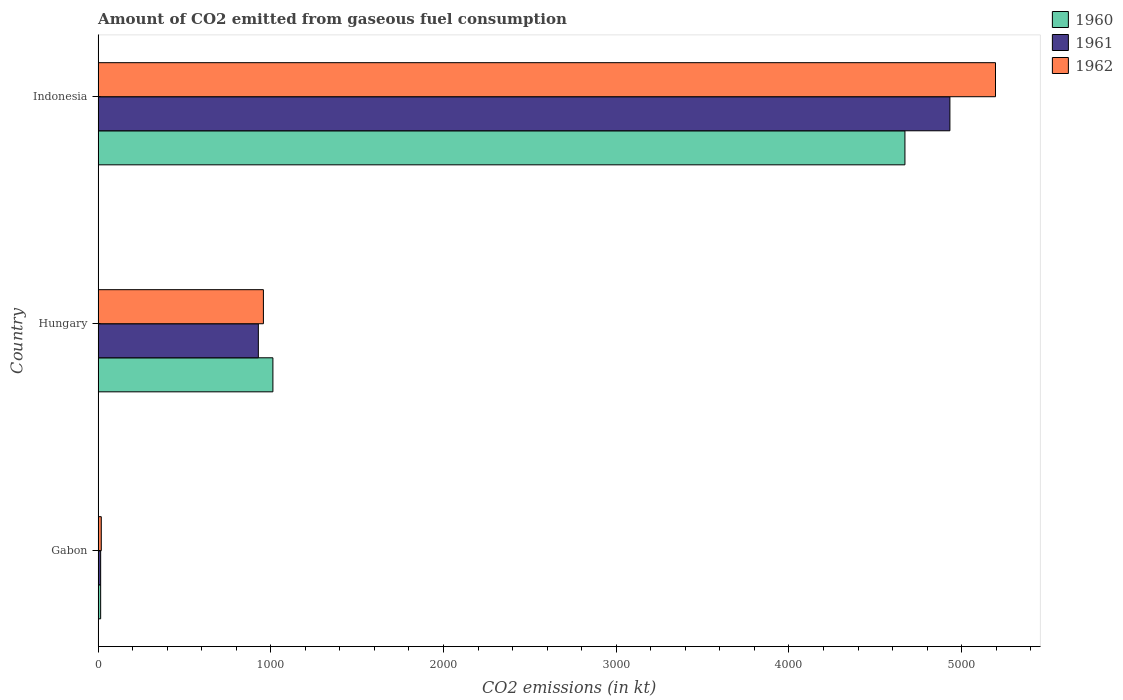How many groups of bars are there?
Your response must be concise. 3. Are the number of bars on each tick of the Y-axis equal?
Your answer should be compact. Yes. What is the label of the 3rd group of bars from the top?
Your answer should be compact. Gabon. In how many cases, is the number of bars for a given country not equal to the number of legend labels?
Provide a short and direct response. 0. What is the amount of CO2 emitted in 1960 in Indonesia?
Offer a very short reply. 4671.76. Across all countries, what is the maximum amount of CO2 emitted in 1962?
Your answer should be compact. 5196.14. Across all countries, what is the minimum amount of CO2 emitted in 1961?
Your response must be concise. 14.67. In which country was the amount of CO2 emitted in 1962 maximum?
Provide a short and direct response. Indonesia. In which country was the amount of CO2 emitted in 1961 minimum?
Offer a terse response. Gabon. What is the total amount of CO2 emitted in 1961 in the graph?
Provide a succinct answer. 5874.53. What is the difference between the amount of CO2 emitted in 1961 in Hungary and that in Indonesia?
Ensure brevity in your answer.  -4004.36. What is the difference between the amount of CO2 emitted in 1960 in Hungary and the amount of CO2 emitted in 1961 in Indonesia?
Keep it short and to the point. -3920.02. What is the average amount of CO2 emitted in 1960 per country?
Your answer should be compact. 1899.51. What is the difference between the amount of CO2 emitted in 1962 and amount of CO2 emitted in 1961 in Gabon?
Keep it short and to the point. 3.67. In how many countries, is the amount of CO2 emitted in 1961 greater than 3600 kt?
Keep it short and to the point. 1. What is the ratio of the amount of CO2 emitted in 1962 in Gabon to that in Indonesia?
Your answer should be very brief. 0. Is the amount of CO2 emitted in 1961 in Gabon less than that in Indonesia?
Make the answer very short. Yes. What is the difference between the highest and the second highest amount of CO2 emitted in 1961?
Keep it short and to the point. 4004.36. What is the difference between the highest and the lowest amount of CO2 emitted in 1962?
Ensure brevity in your answer.  5177.8. What does the 2nd bar from the top in Indonesia represents?
Ensure brevity in your answer.  1961. What does the 1st bar from the bottom in Gabon represents?
Ensure brevity in your answer.  1960. Is it the case that in every country, the sum of the amount of CO2 emitted in 1961 and amount of CO2 emitted in 1960 is greater than the amount of CO2 emitted in 1962?
Your answer should be very brief. Yes. Are all the bars in the graph horizontal?
Make the answer very short. Yes. How many countries are there in the graph?
Offer a terse response. 3. Does the graph contain grids?
Make the answer very short. No. Where does the legend appear in the graph?
Your answer should be compact. Top right. How many legend labels are there?
Provide a short and direct response. 3. How are the legend labels stacked?
Your response must be concise. Vertical. What is the title of the graph?
Provide a succinct answer. Amount of CO2 emitted from gaseous fuel consumption. What is the label or title of the X-axis?
Keep it short and to the point. CO2 emissions (in kt). What is the label or title of the Y-axis?
Provide a succinct answer. Country. What is the CO2 emissions (in kt) of 1960 in Gabon?
Your answer should be very brief. 14.67. What is the CO2 emissions (in kt) of 1961 in Gabon?
Offer a very short reply. 14.67. What is the CO2 emissions (in kt) in 1962 in Gabon?
Give a very brief answer. 18.34. What is the CO2 emissions (in kt) of 1960 in Hungary?
Provide a short and direct response. 1012.09. What is the CO2 emissions (in kt) of 1961 in Hungary?
Ensure brevity in your answer.  927.75. What is the CO2 emissions (in kt) in 1962 in Hungary?
Keep it short and to the point. 957.09. What is the CO2 emissions (in kt) of 1960 in Indonesia?
Ensure brevity in your answer.  4671.76. What is the CO2 emissions (in kt) of 1961 in Indonesia?
Your answer should be compact. 4932.11. What is the CO2 emissions (in kt) in 1962 in Indonesia?
Your response must be concise. 5196.14. Across all countries, what is the maximum CO2 emissions (in kt) of 1960?
Offer a terse response. 4671.76. Across all countries, what is the maximum CO2 emissions (in kt) in 1961?
Ensure brevity in your answer.  4932.11. Across all countries, what is the maximum CO2 emissions (in kt) in 1962?
Your response must be concise. 5196.14. Across all countries, what is the minimum CO2 emissions (in kt) of 1960?
Provide a succinct answer. 14.67. Across all countries, what is the minimum CO2 emissions (in kt) in 1961?
Ensure brevity in your answer.  14.67. Across all countries, what is the minimum CO2 emissions (in kt) in 1962?
Offer a terse response. 18.34. What is the total CO2 emissions (in kt) of 1960 in the graph?
Offer a terse response. 5698.52. What is the total CO2 emissions (in kt) of 1961 in the graph?
Ensure brevity in your answer.  5874.53. What is the total CO2 emissions (in kt) in 1962 in the graph?
Give a very brief answer. 6171.56. What is the difference between the CO2 emissions (in kt) in 1960 in Gabon and that in Hungary?
Give a very brief answer. -997.42. What is the difference between the CO2 emissions (in kt) in 1961 in Gabon and that in Hungary?
Your answer should be compact. -913.08. What is the difference between the CO2 emissions (in kt) in 1962 in Gabon and that in Hungary?
Offer a terse response. -938.75. What is the difference between the CO2 emissions (in kt) of 1960 in Gabon and that in Indonesia?
Make the answer very short. -4657.09. What is the difference between the CO2 emissions (in kt) in 1961 in Gabon and that in Indonesia?
Make the answer very short. -4917.45. What is the difference between the CO2 emissions (in kt) in 1962 in Gabon and that in Indonesia?
Give a very brief answer. -5177.8. What is the difference between the CO2 emissions (in kt) of 1960 in Hungary and that in Indonesia?
Your answer should be very brief. -3659.67. What is the difference between the CO2 emissions (in kt) of 1961 in Hungary and that in Indonesia?
Make the answer very short. -4004.36. What is the difference between the CO2 emissions (in kt) in 1962 in Hungary and that in Indonesia?
Your answer should be compact. -4239.05. What is the difference between the CO2 emissions (in kt) in 1960 in Gabon and the CO2 emissions (in kt) in 1961 in Hungary?
Provide a short and direct response. -913.08. What is the difference between the CO2 emissions (in kt) of 1960 in Gabon and the CO2 emissions (in kt) of 1962 in Hungary?
Give a very brief answer. -942.42. What is the difference between the CO2 emissions (in kt) in 1961 in Gabon and the CO2 emissions (in kt) in 1962 in Hungary?
Ensure brevity in your answer.  -942.42. What is the difference between the CO2 emissions (in kt) in 1960 in Gabon and the CO2 emissions (in kt) in 1961 in Indonesia?
Keep it short and to the point. -4917.45. What is the difference between the CO2 emissions (in kt) of 1960 in Gabon and the CO2 emissions (in kt) of 1962 in Indonesia?
Provide a succinct answer. -5181.47. What is the difference between the CO2 emissions (in kt) of 1961 in Gabon and the CO2 emissions (in kt) of 1962 in Indonesia?
Keep it short and to the point. -5181.47. What is the difference between the CO2 emissions (in kt) of 1960 in Hungary and the CO2 emissions (in kt) of 1961 in Indonesia?
Provide a succinct answer. -3920.02. What is the difference between the CO2 emissions (in kt) in 1960 in Hungary and the CO2 emissions (in kt) in 1962 in Indonesia?
Provide a succinct answer. -4184.05. What is the difference between the CO2 emissions (in kt) in 1961 in Hungary and the CO2 emissions (in kt) in 1962 in Indonesia?
Give a very brief answer. -4268.39. What is the average CO2 emissions (in kt) in 1960 per country?
Your response must be concise. 1899.51. What is the average CO2 emissions (in kt) in 1961 per country?
Provide a short and direct response. 1958.18. What is the average CO2 emissions (in kt) in 1962 per country?
Your response must be concise. 2057.19. What is the difference between the CO2 emissions (in kt) in 1960 and CO2 emissions (in kt) in 1962 in Gabon?
Provide a succinct answer. -3.67. What is the difference between the CO2 emissions (in kt) of 1961 and CO2 emissions (in kt) of 1962 in Gabon?
Provide a short and direct response. -3.67. What is the difference between the CO2 emissions (in kt) of 1960 and CO2 emissions (in kt) of 1961 in Hungary?
Provide a succinct answer. 84.34. What is the difference between the CO2 emissions (in kt) in 1960 and CO2 emissions (in kt) in 1962 in Hungary?
Your answer should be very brief. 55.01. What is the difference between the CO2 emissions (in kt) of 1961 and CO2 emissions (in kt) of 1962 in Hungary?
Give a very brief answer. -29.34. What is the difference between the CO2 emissions (in kt) in 1960 and CO2 emissions (in kt) in 1961 in Indonesia?
Your response must be concise. -260.36. What is the difference between the CO2 emissions (in kt) in 1960 and CO2 emissions (in kt) in 1962 in Indonesia?
Keep it short and to the point. -524.38. What is the difference between the CO2 emissions (in kt) in 1961 and CO2 emissions (in kt) in 1962 in Indonesia?
Your response must be concise. -264.02. What is the ratio of the CO2 emissions (in kt) of 1960 in Gabon to that in Hungary?
Keep it short and to the point. 0.01. What is the ratio of the CO2 emissions (in kt) of 1961 in Gabon to that in Hungary?
Provide a succinct answer. 0.02. What is the ratio of the CO2 emissions (in kt) of 1962 in Gabon to that in Hungary?
Your response must be concise. 0.02. What is the ratio of the CO2 emissions (in kt) of 1960 in Gabon to that in Indonesia?
Offer a terse response. 0. What is the ratio of the CO2 emissions (in kt) in 1961 in Gabon to that in Indonesia?
Give a very brief answer. 0. What is the ratio of the CO2 emissions (in kt) in 1962 in Gabon to that in Indonesia?
Your answer should be very brief. 0. What is the ratio of the CO2 emissions (in kt) of 1960 in Hungary to that in Indonesia?
Provide a short and direct response. 0.22. What is the ratio of the CO2 emissions (in kt) of 1961 in Hungary to that in Indonesia?
Provide a succinct answer. 0.19. What is the ratio of the CO2 emissions (in kt) of 1962 in Hungary to that in Indonesia?
Your response must be concise. 0.18. What is the difference between the highest and the second highest CO2 emissions (in kt) of 1960?
Give a very brief answer. 3659.67. What is the difference between the highest and the second highest CO2 emissions (in kt) of 1961?
Provide a succinct answer. 4004.36. What is the difference between the highest and the second highest CO2 emissions (in kt) of 1962?
Provide a succinct answer. 4239.05. What is the difference between the highest and the lowest CO2 emissions (in kt) of 1960?
Ensure brevity in your answer.  4657.09. What is the difference between the highest and the lowest CO2 emissions (in kt) of 1961?
Your answer should be compact. 4917.45. What is the difference between the highest and the lowest CO2 emissions (in kt) of 1962?
Keep it short and to the point. 5177.8. 